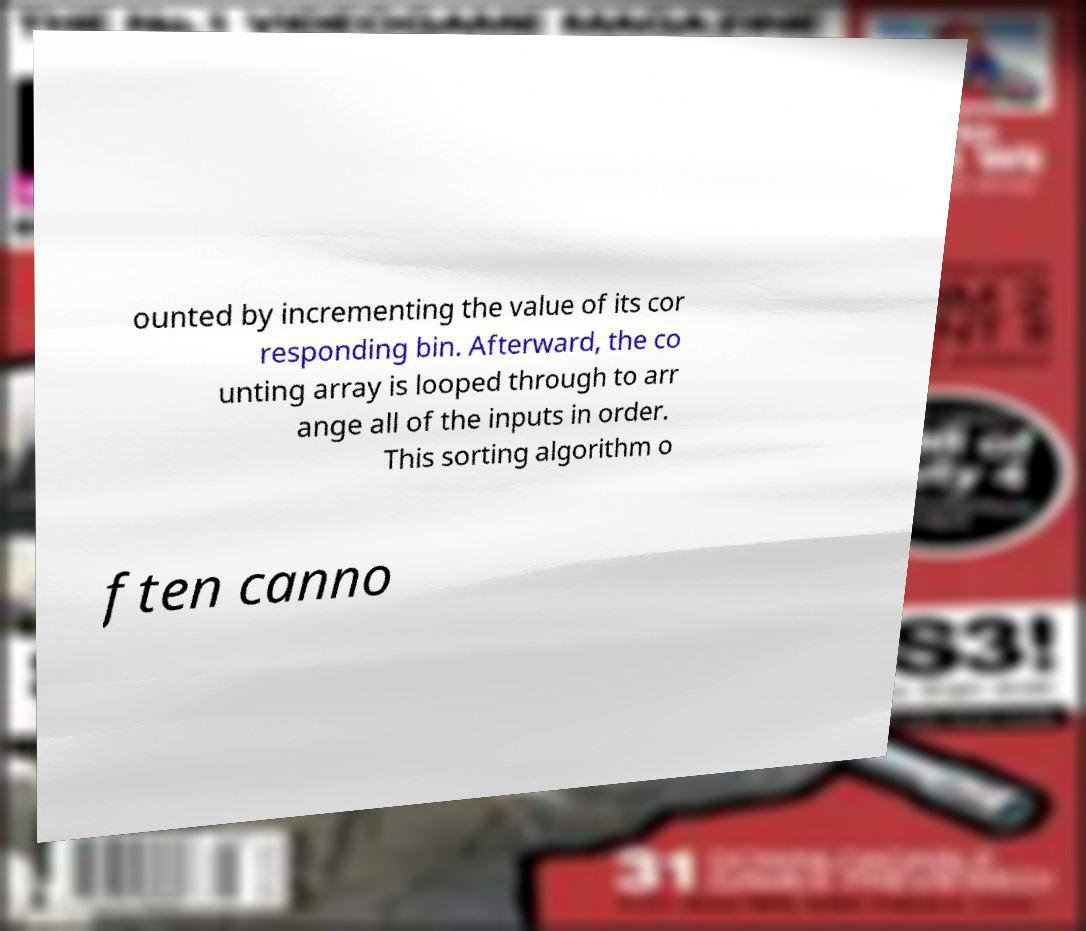Can you read and provide the text displayed in the image?This photo seems to have some interesting text. Can you extract and type it out for me? ounted by incrementing the value of its cor responding bin. Afterward, the co unting array is looped through to arr ange all of the inputs in order. This sorting algorithm o ften canno 